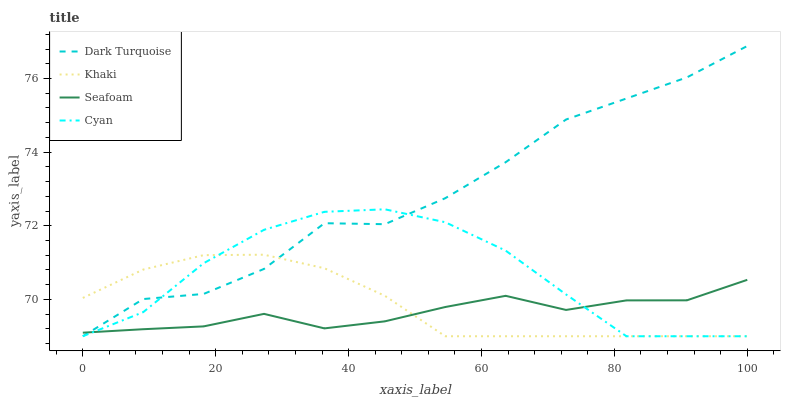Does Seafoam have the minimum area under the curve?
Answer yes or no. Yes. Does Dark Turquoise have the maximum area under the curve?
Answer yes or no. Yes. Does Khaki have the minimum area under the curve?
Answer yes or no. No. Does Khaki have the maximum area under the curve?
Answer yes or no. No. Is Khaki the smoothest?
Answer yes or no. Yes. Is Dark Turquoise the roughest?
Answer yes or no. Yes. Is Seafoam the smoothest?
Answer yes or no. No. Is Seafoam the roughest?
Answer yes or no. No. Does Dark Turquoise have the lowest value?
Answer yes or no. Yes. Does Seafoam have the lowest value?
Answer yes or no. No. Does Dark Turquoise have the highest value?
Answer yes or no. Yes. Does Khaki have the highest value?
Answer yes or no. No. Does Khaki intersect Cyan?
Answer yes or no. Yes. Is Khaki less than Cyan?
Answer yes or no. No. Is Khaki greater than Cyan?
Answer yes or no. No. 